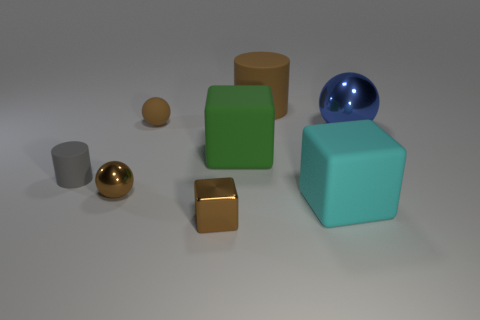Add 1 large blue spheres. How many objects exist? 9 Subtract all cylinders. How many objects are left? 6 Subtract all cyan things. Subtract all small brown metal spheres. How many objects are left? 6 Add 5 large blue objects. How many large blue objects are left? 6 Add 4 small objects. How many small objects exist? 8 Subtract 1 brown cubes. How many objects are left? 7 